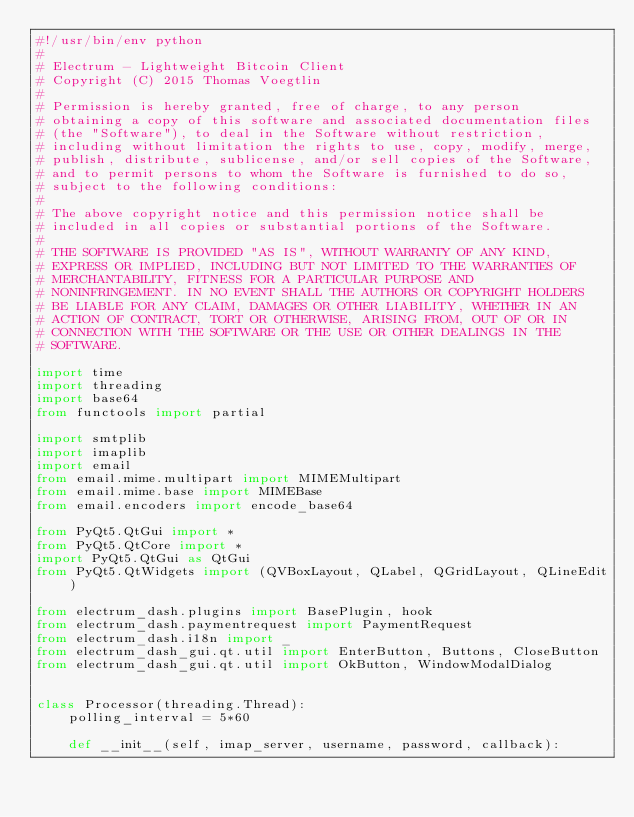Convert code to text. <code><loc_0><loc_0><loc_500><loc_500><_Python_>#!/usr/bin/env python
#
# Electrum - Lightweight Bitcoin Client
# Copyright (C) 2015 Thomas Voegtlin
#
# Permission is hereby granted, free of charge, to any person
# obtaining a copy of this software and associated documentation files
# (the "Software"), to deal in the Software without restriction,
# including without limitation the rights to use, copy, modify, merge,
# publish, distribute, sublicense, and/or sell copies of the Software,
# and to permit persons to whom the Software is furnished to do so,
# subject to the following conditions:
#
# The above copyright notice and this permission notice shall be
# included in all copies or substantial portions of the Software.
#
# THE SOFTWARE IS PROVIDED "AS IS", WITHOUT WARRANTY OF ANY KIND,
# EXPRESS OR IMPLIED, INCLUDING BUT NOT LIMITED TO THE WARRANTIES OF
# MERCHANTABILITY, FITNESS FOR A PARTICULAR PURPOSE AND
# NONINFRINGEMENT. IN NO EVENT SHALL THE AUTHORS OR COPYRIGHT HOLDERS
# BE LIABLE FOR ANY CLAIM, DAMAGES OR OTHER LIABILITY, WHETHER IN AN
# ACTION OF CONTRACT, TORT OR OTHERWISE, ARISING FROM, OUT OF OR IN
# CONNECTION WITH THE SOFTWARE OR THE USE OR OTHER DEALINGS IN THE
# SOFTWARE.

import time
import threading
import base64
from functools import partial

import smtplib
import imaplib
import email
from email.mime.multipart import MIMEMultipart
from email.mime.base import MIMEBase
from email.encoders import encode_base64

from PyQt5.QtGui import *
from PyQt5.QtCore import *
import PyQt5.QtGui as QtGui
from PyQt5.QtWidgets import (QVBoxLayout, QLabel, QGridLayout, QLineEdit)

from electrum_dash.plugins import BasePlugin, hook
from electrum_dash.paymentrequest import PaymentRequest
from electrum_dash.i18n import _
from electrum_dash_gui.qt.util import EnterButton, Buttons, CloseButton
from electrum_dash_gui.qt.util import OkButton, WindowModalDialog


class Processor(threading.Thread):
    polling_interval = 5*60

    def __init__(self, imap_server, username, password, callback):</code> 